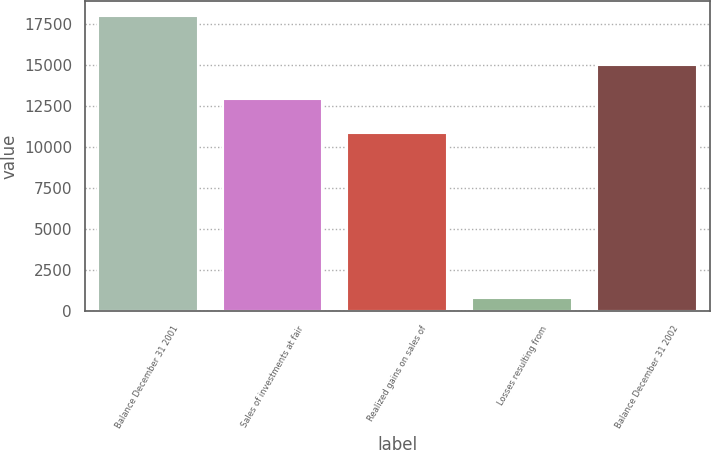Convert chart to OTSL. <chart><loc_0><loc_0><loc_500><loc_500><bar_chart><fcel>Balance December 31 2001<fcel>Sales of investments at fair<fcel>Realized gains on sales of<fcel>Losses resulting from<fcel>Balance December 31 2002<nl><fcel>17972<fcel>12941<fcel>10844<fcel>794<fcel>15006<nl></chart> 